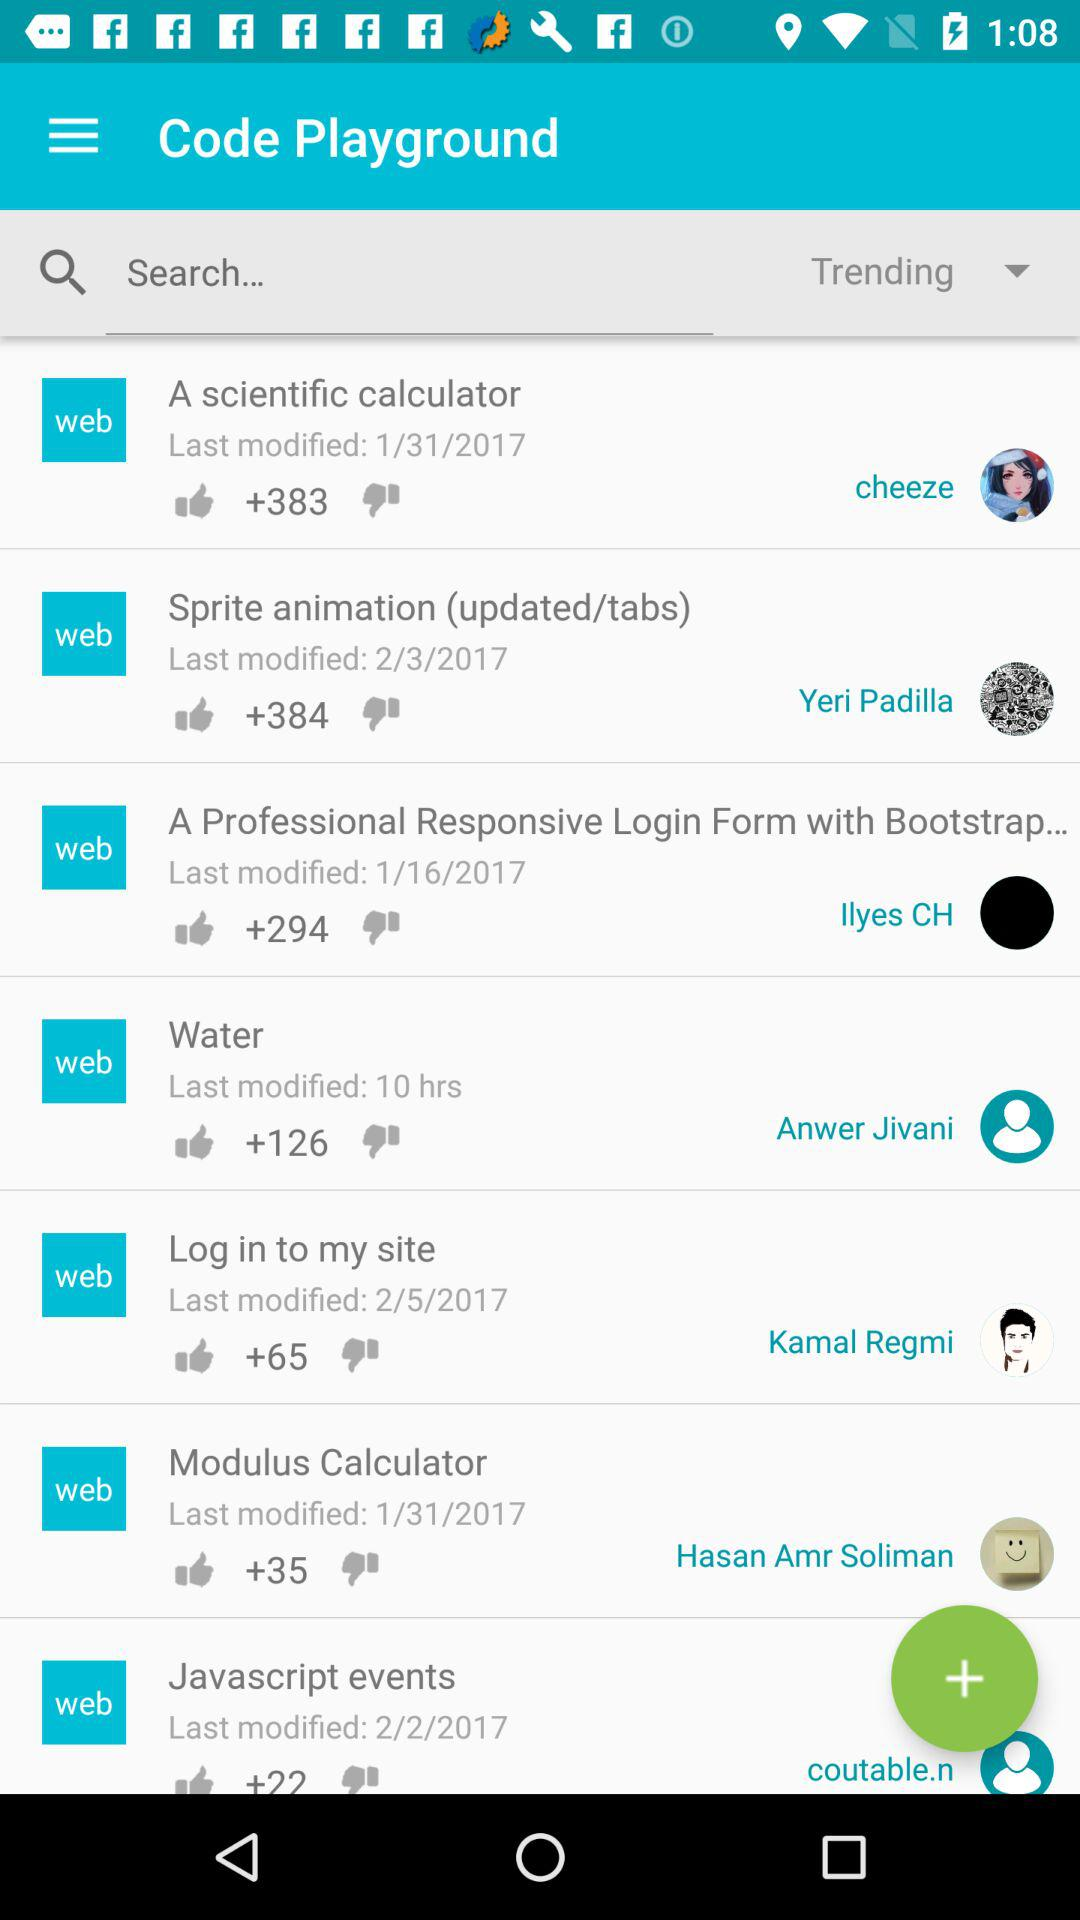How many thumbs up does the item with the most thumbs up have?
Answer the question using a single word or phrase. 384 